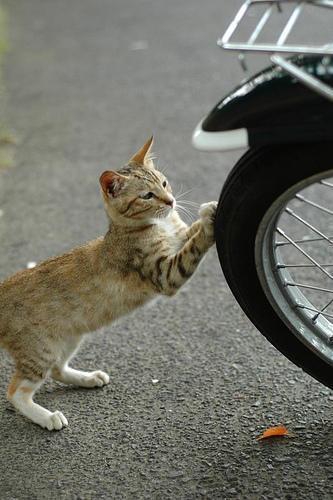What could potentially puncture the tire?
Indicate the correct response by choosing from the four available options to answer the question.
Options: Fur, claws, eyes, ears. Claws. 